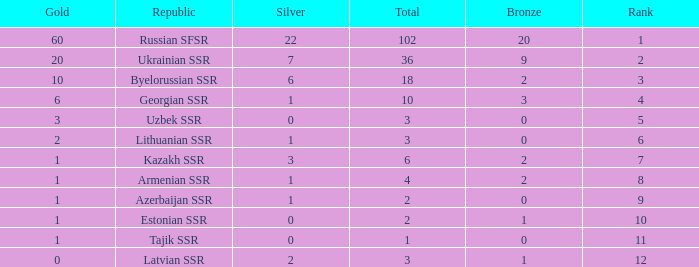What is the average total for teams with more than 1 gold, ranked over 3 and more than 3 bronze? None. 